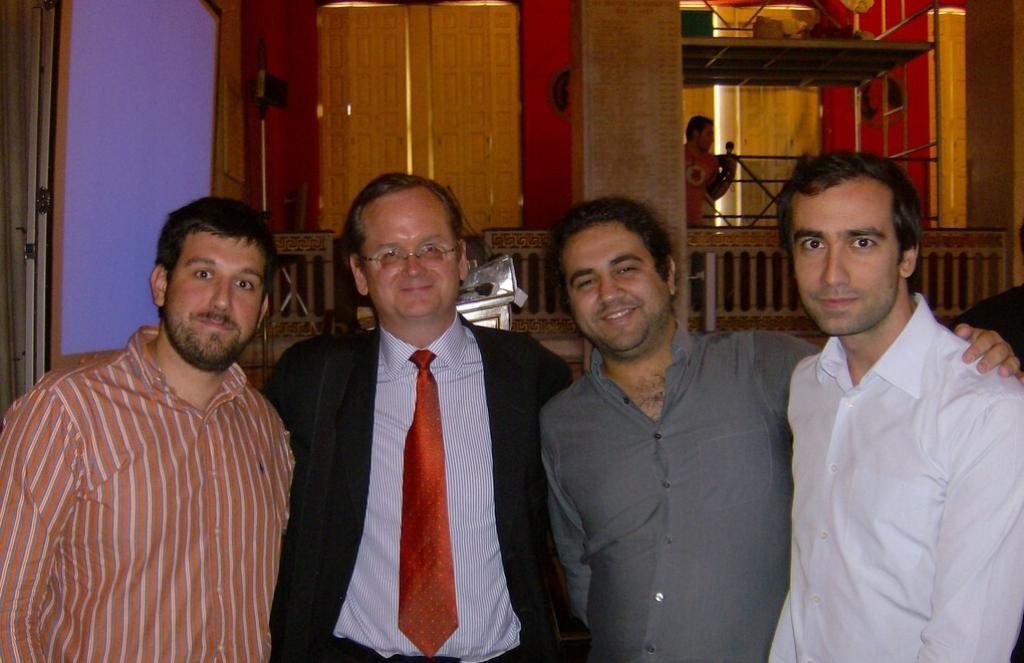How would you summarize this image in a sentence or two? In the image few people are standing and smiling. Behind them there is wall and fencing. Behind the fencing a man is standing and holding something in his hand. 